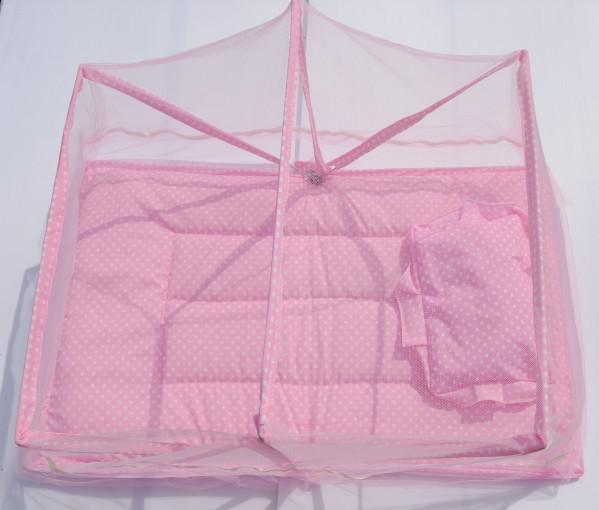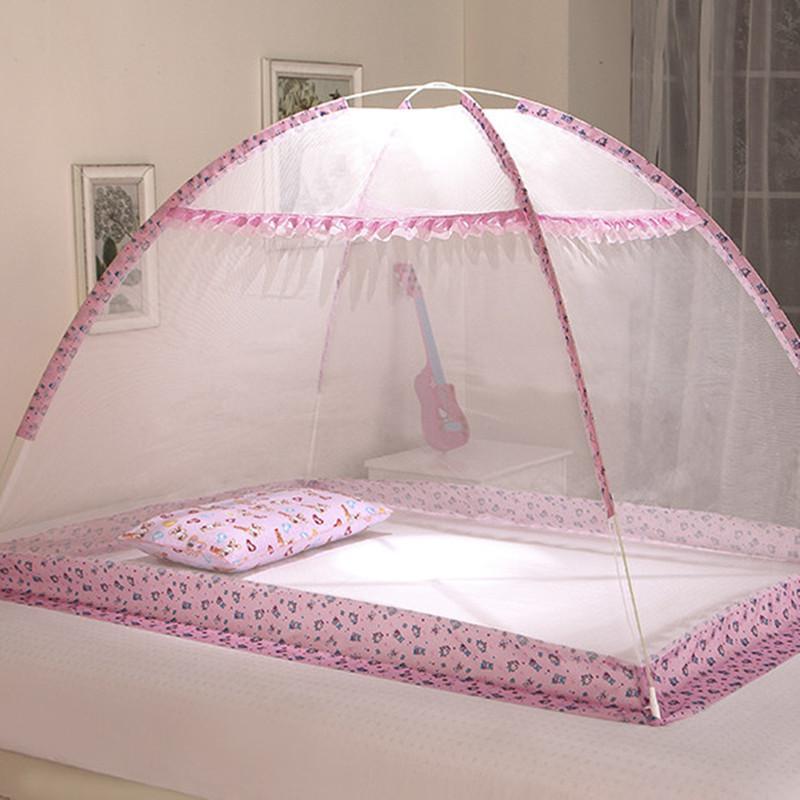The first image is the image on the left, the second image is the image on the right. Considering the images on both sides, is "One of the baby sleeper items is blue." valid? Answer yes or no. No. 